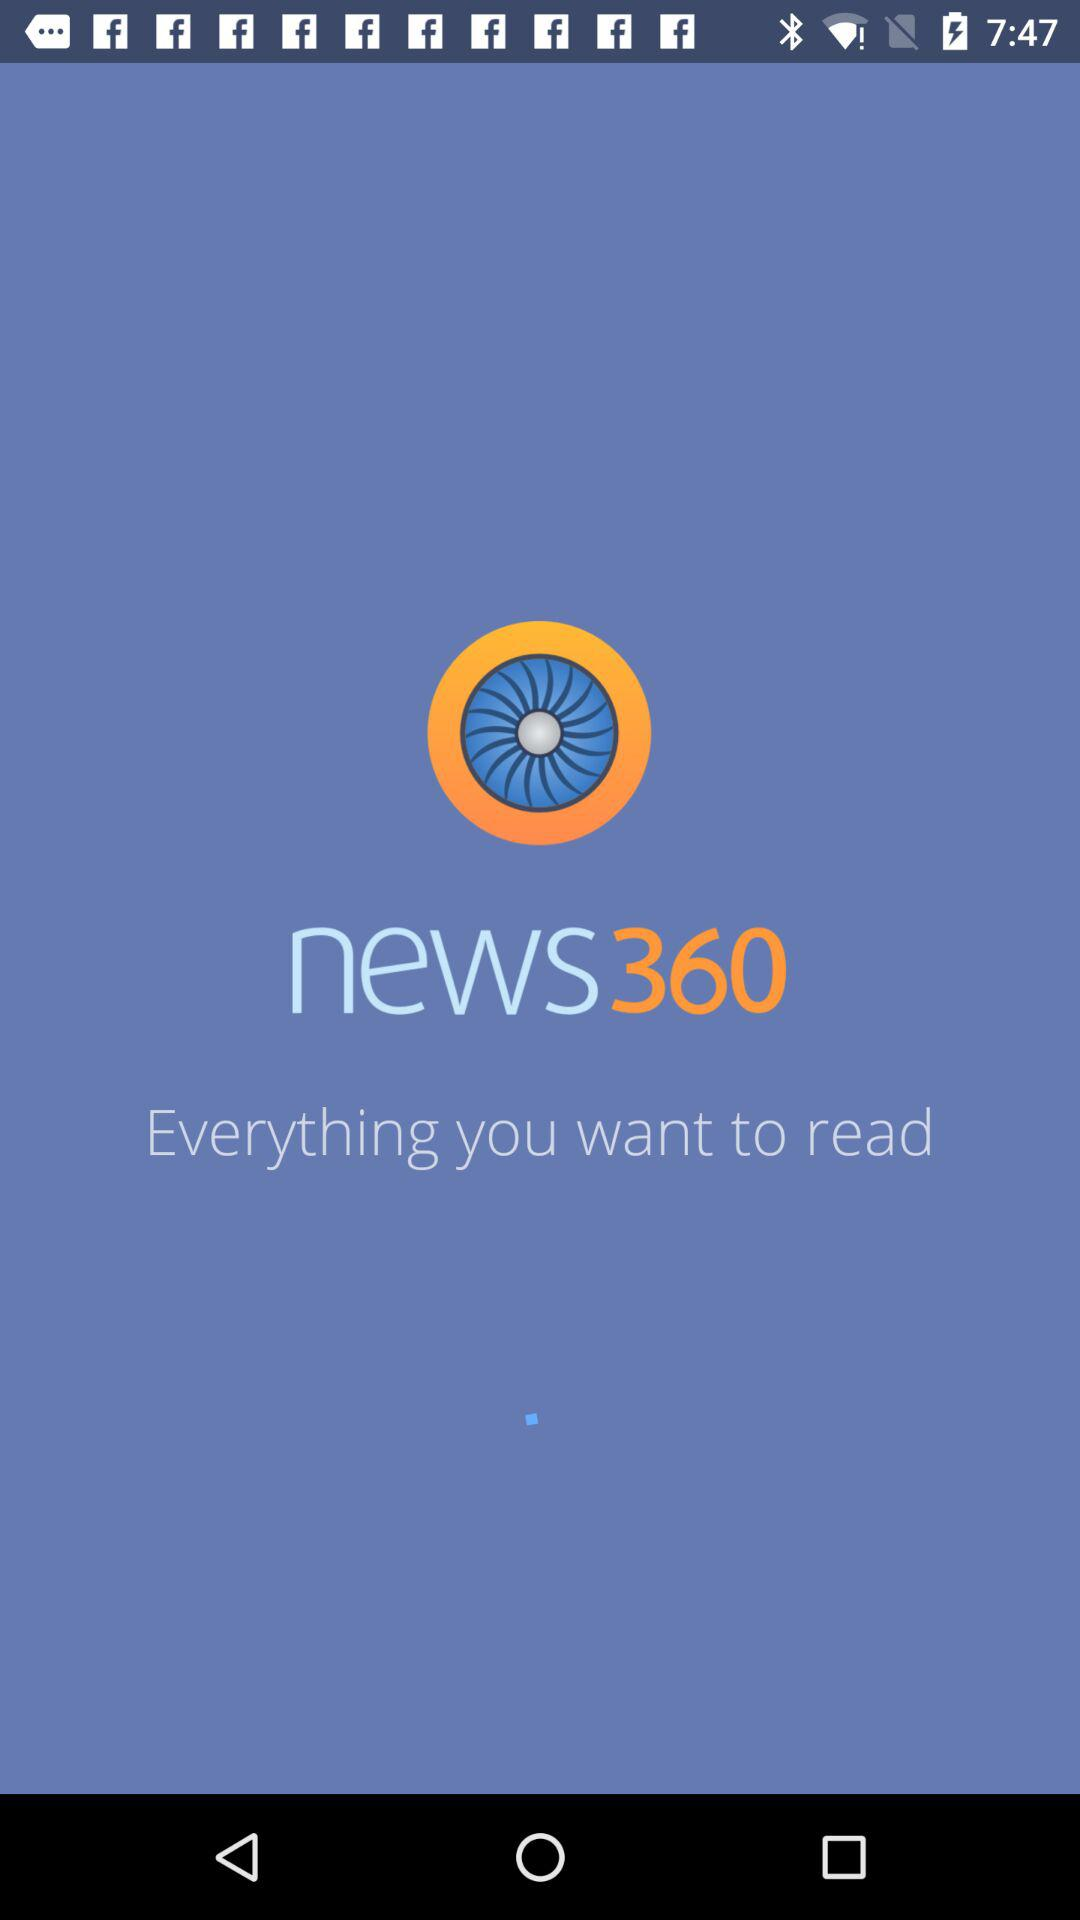What is the name of the application? The name of the application is "news360". 